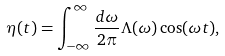<formula> <loc_0><loc_0><loc_500><loc_500>\eta ( t ) = \int _ { - \infty } ^ { \infty } \frac { d \omega } { 2 \pi } \Lambda ( \omega ) \cos ( \omega t ) ,</formula> 